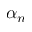Convert formula to latex. <formula><loc_0><loc_0><loc_500><loc_500>\alpha _ { n }</formula> 